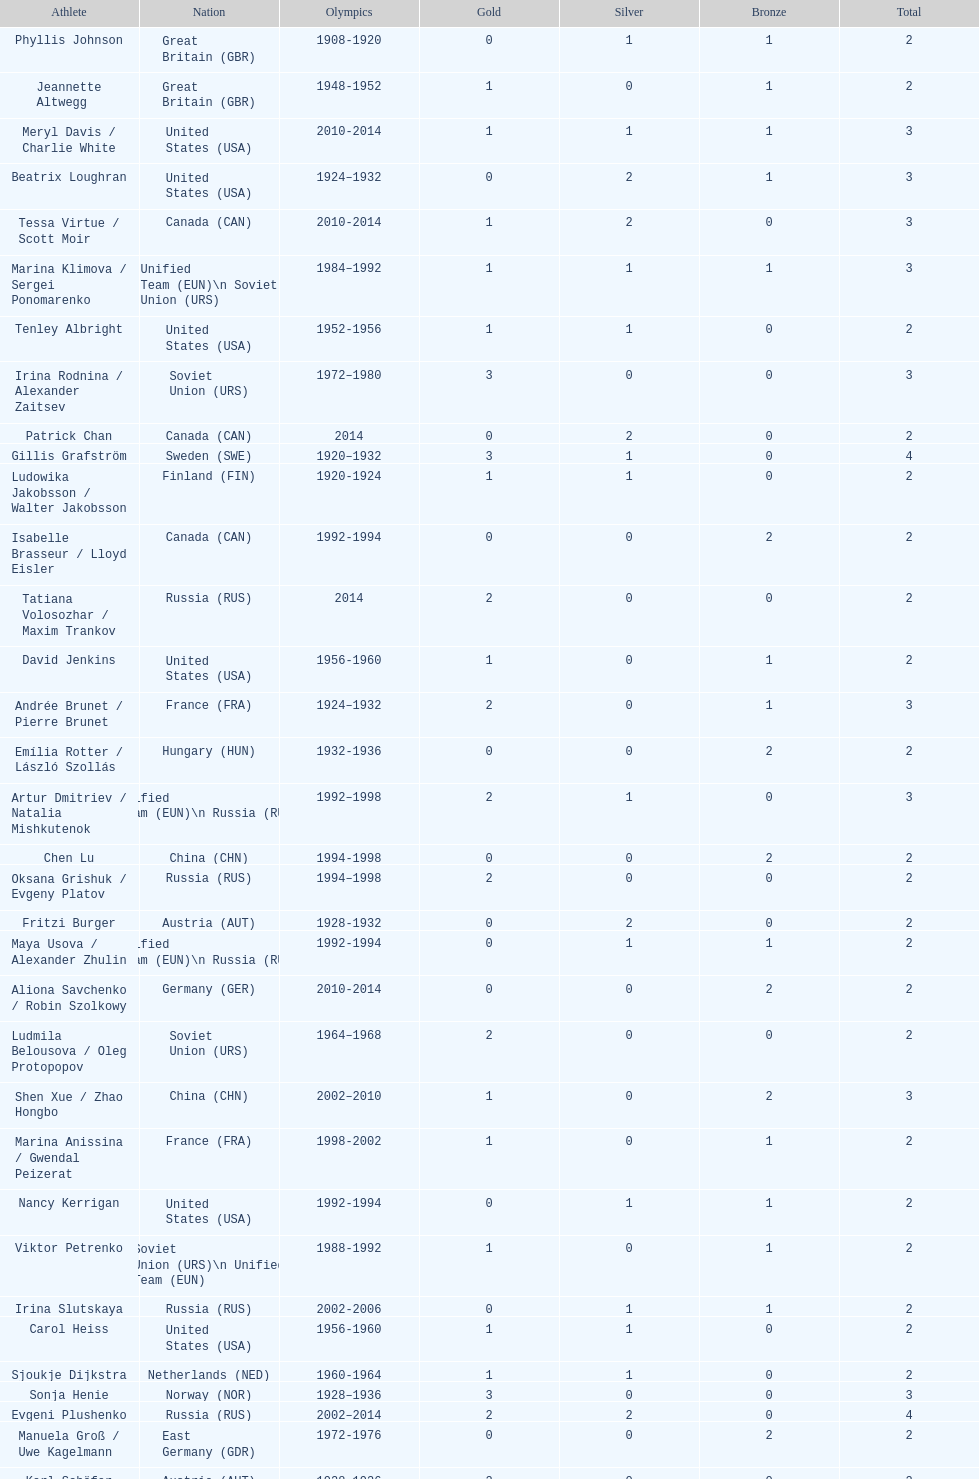Which athlete was from south korea after the year 2010? Kim Yu-na. 